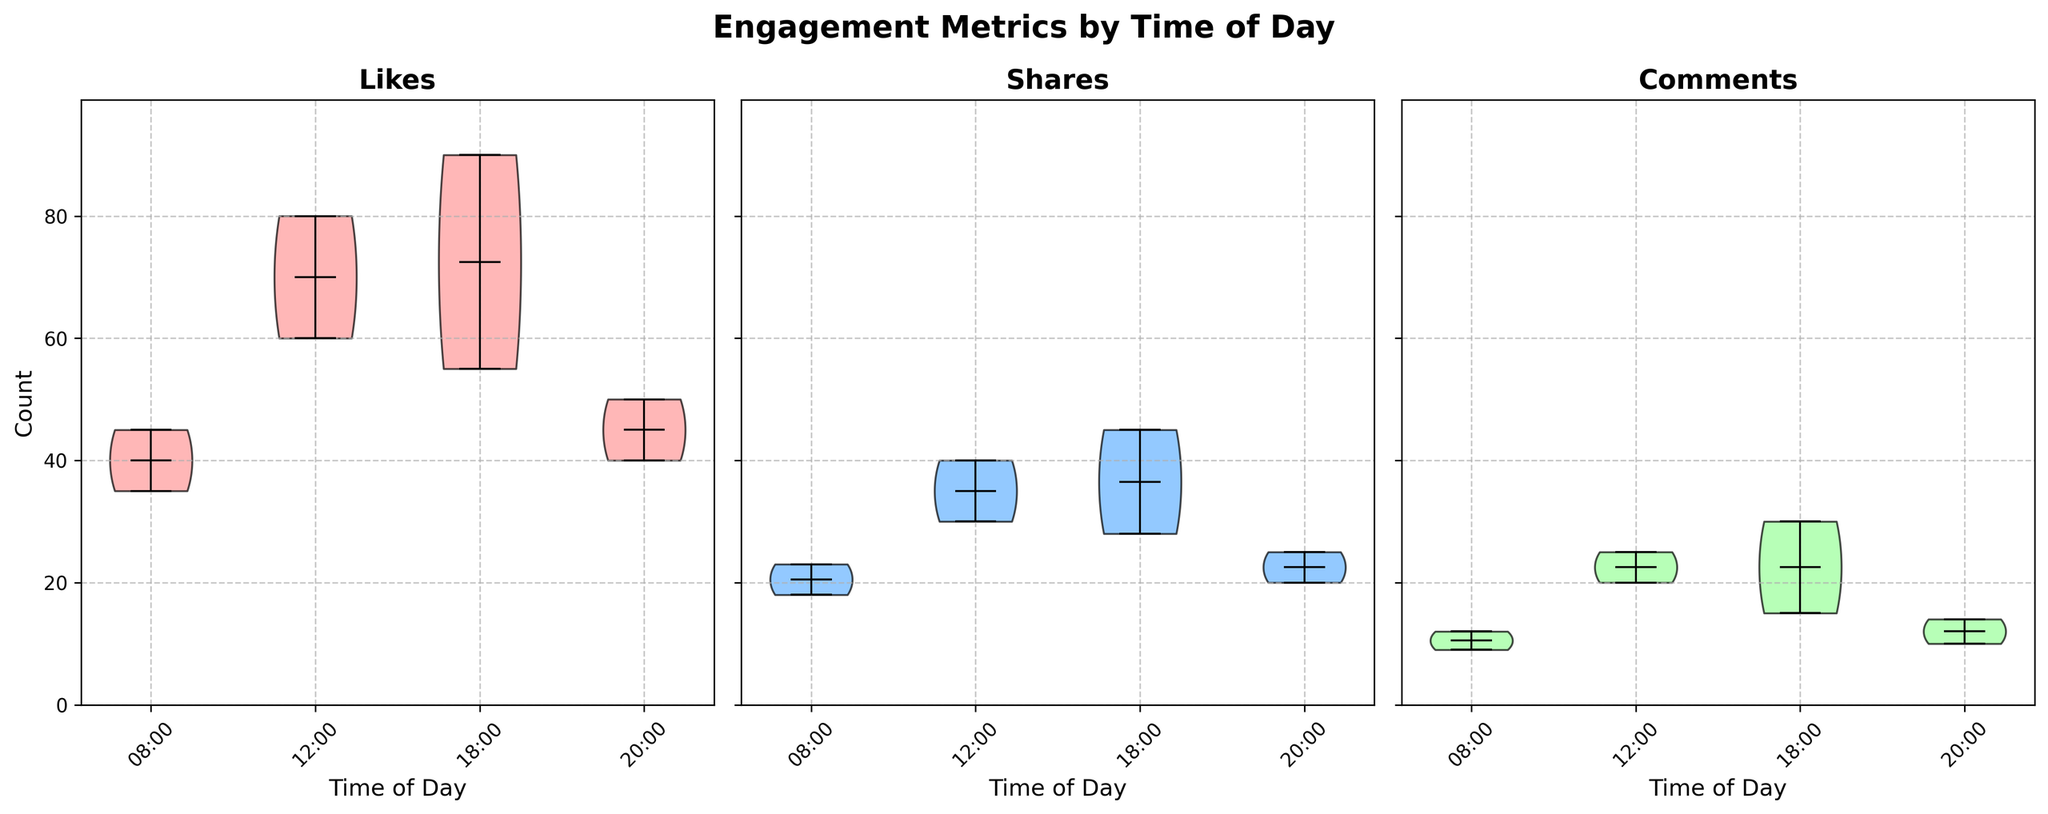What is the title of the plot? The title can be found at the top of the figure. It provides an overview of what the chart represents.
Answer: Engagement Metrics by Time of Day Which time of day shows the highest median number of likes? Look for the median markers (horizontal lines within the violins) in the 'Likes' subplot. The highest median is indicated by the horizontal line located furthest up the y-axis.
Answer: 18:00 From the 'Shares' subplot, what is the range of values at 12:00? To find the range, identify the top and bottom parts of the violin plot for 'Shares' at 12:00. The range is the difference between these two values.
Answer: 0 - 45 How do the distributions of 'Comments' vary between 08:00 and 18:00? Compare the density and spread of the violins in the 'Comments' subplot at 08:00 and 18:00. Note differences in width, height, and shape to determine variation.
Answer: 18:00 has higher values and a wider distribution than 08:00 In the 'Likes' subplot, which time of day has the smallest spread of values? The smallest spread is where the violin plot is narrowest on the y-axis. Compare the width of each violin to determine the time with the least variability in 'Likes'.
Answer: 08:00 Which engagement metric has the most skewed distribution across all times? Look for which subplot has the most asymmetric violins. Skewness is evident if one side of the violin is larger or more extended.
Answer: Likes Are the mean values for 'Shares' higher at 12:00 or 20:00? The mean is shown by a white dot within the violin plot. Compare the mean values (white dots) in the 'Shares' subplot for 12:00 and 20:00.
Answer: 12:00 How does the distribution of 'Shares' at 18:00 compare to that at 20:00? Examine the 'Shares' subplot for the violins at 18:00 and 20:00. Note the shape, spread, and center values to compare the distributions.
Answer: 18:00 has a wider spread and higher center values What is the maximum value recorded for 'Comments' in the entire dataset? Maximum values are indicated by the top part of the violin plot in the 'Comments' subplot. Find the highest point across all times.
Answer: 30 